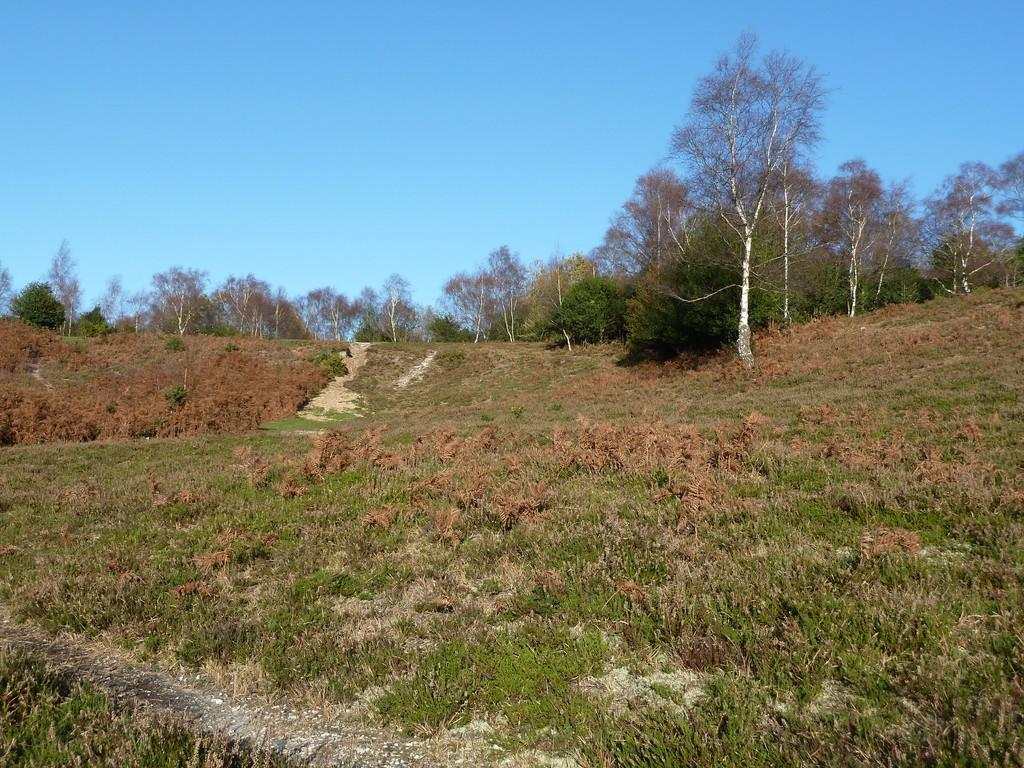What type of surface is on the floor in the image? There is grass on the floor in the image. What can be seen in the background of the image? There are plants and trees visible in the image. What is the condition of the sky in the image? The sky is clear in the image. What type of cheese is being used to whip the plants in the image? There is no cheese or whipping action present in the image. The image features grass on the floor, plants and trees in the background, and a clear sky. 